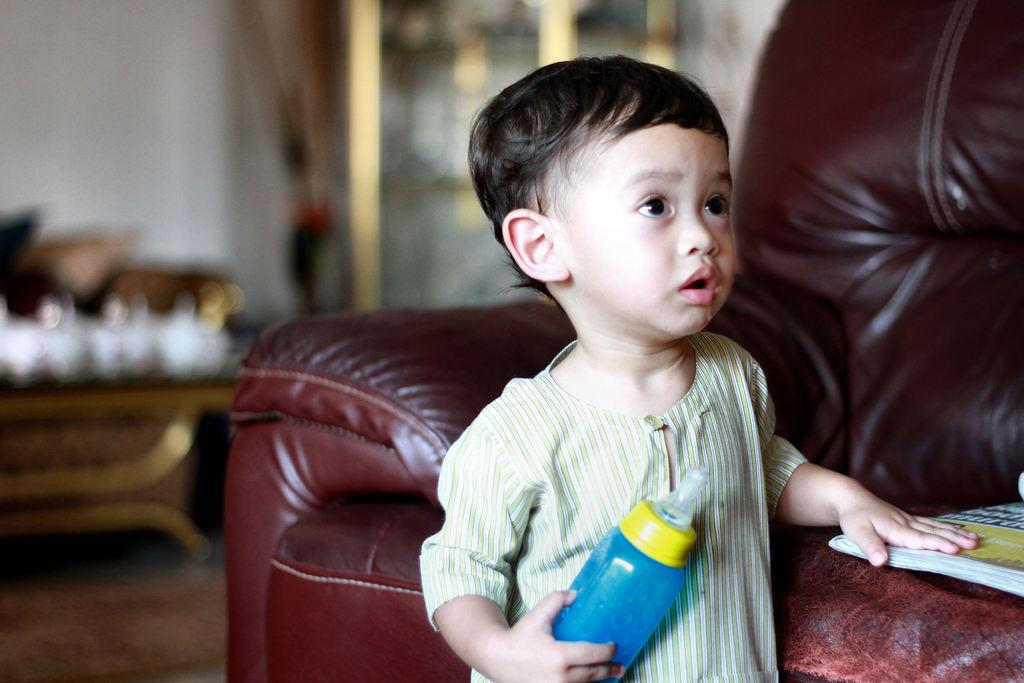Who is the main subject in the image? There is a boy in the image. What is the boy doing in the image? The boy is standing in the image. What is the boy holding in his hand? The boy is holding a milk bottle in his hand. Where is the boy standing in relation to the furniture? The boy is standing by the side of a sofa. What direction is the boy looking in the image? The boy is looking up. What type of jam is the boy spreading on the boundary in the image? There is no jam or boundary present in the image; it features a boy standing by a sofa, holding a milk bottle, and looking up. 